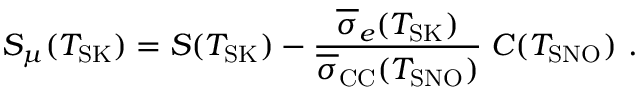Convert formula to latex. <formula><loc_0><loc_0><loc_500><loc_500>S _ { \mu } ( T _ { S K } ) = S ( T _ { S K } ) - \frac { \overline { \sigma } _ { e } ( T _ { S K } ) } { \overline { \sigma } _ { C C } ( T _ { S N O } ) } \, C ( T _ { S N O } ) .</formula> 